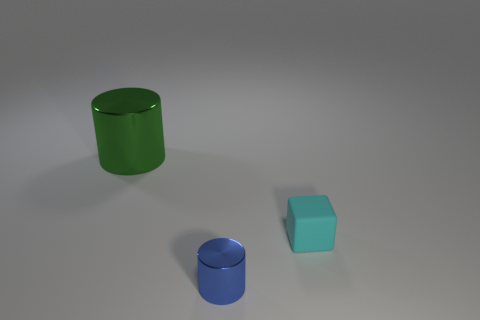Add 3 big brown metal cylinders. How many objects exist? 6 Subtract 1 cylinders. How many cylinders are left? 1 Subtract all purple spheres. How many blue cylinders are left? 1 Subtract all small gray cylinders. Subtract all metallic cylinders. How many objects are left? 1 Add 2 big things. How many big things are left? 3 Add 2 tiny purple shiny spheres. How many tiny purple shiny spheres exist? 2 Subtract 0 gray cylinders. How many objects are left? 3 Subtract all cylinders. How many objects are left? 1 Subtract all gray cylinders. Subtract all purple balls. How many cylinders are left? 2 